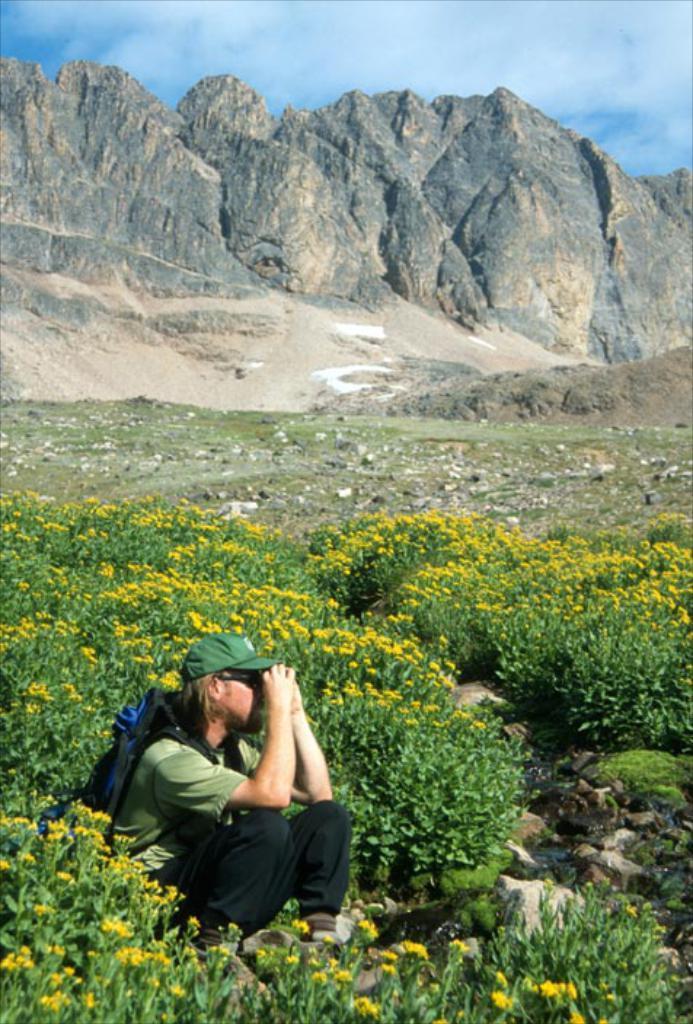Could you give a brief overview of what you see in this image? At the bottom of the image, we can see a person is sitting and wearing a backpack and cap. Here we can see few plants, flowers, stones and water. Background we can see hills and sky. 